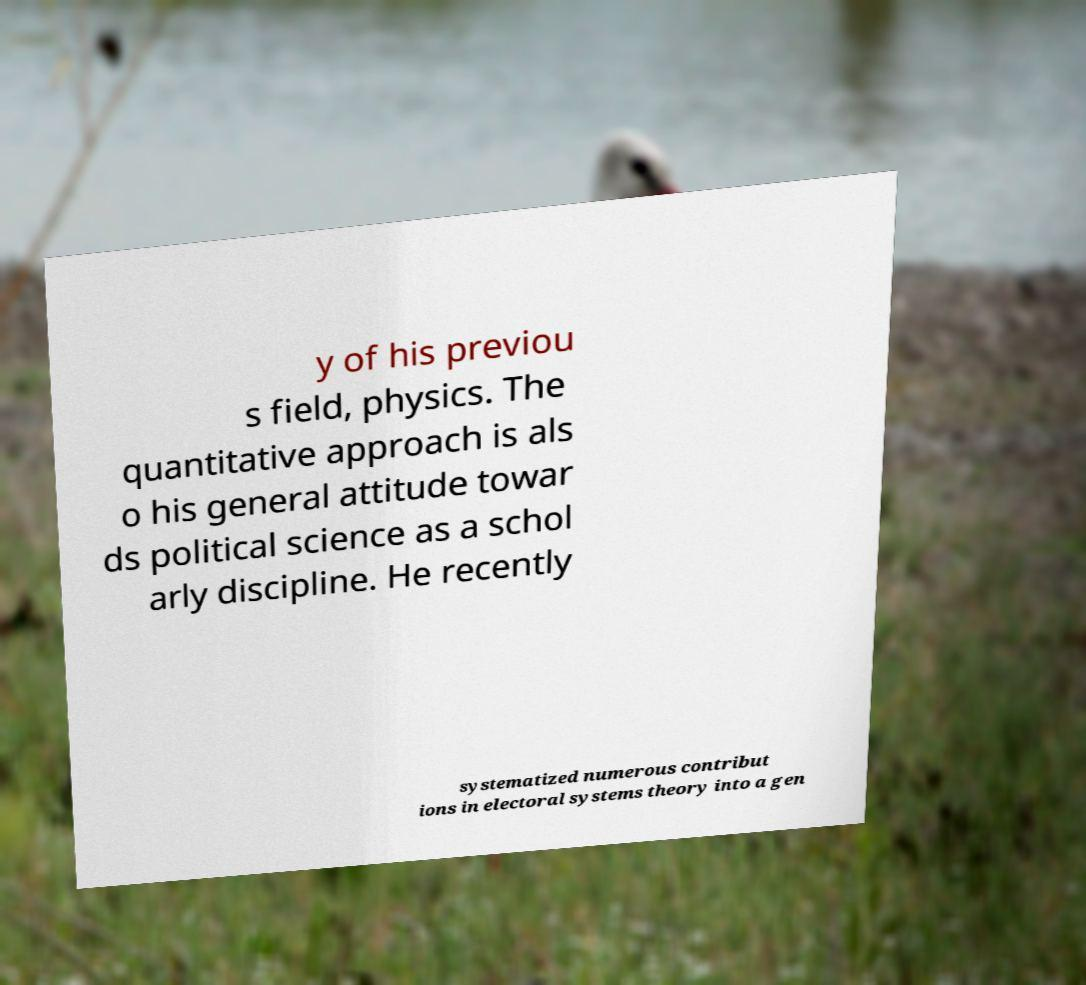What messages or text are displayed in this image? I need them in a readable, typed format. y of his previou s field, physics. The quantitative approach is als o his general attitude towar ds political science as a schol arly discipline. He recently systematized numerous contribut ions in electoral systems theory into a gen 